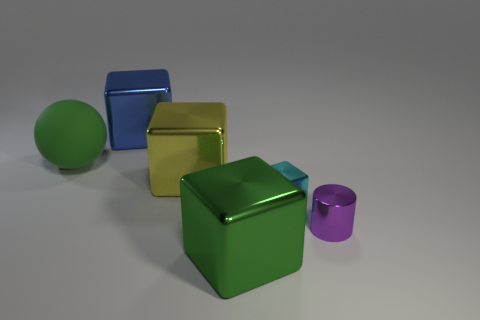Subtract all green blocks. How many blocks are left? 3 Add 3 cylinders. How many objects exist? 9 Subtract all green blocks. How many blocks are left? 3 Subtract all yellow spheres. How many blue cylinders are left? 0 Add 3 small cylinders. How many small cylinders exist? 4 Subtract 1 purple cylinders. How many objects are left? 5 Subtract all cubes. How many objects are left? 2 Subtract all cyan cubes. Subtract all blue balls. How many cubes are left? 3 Subtract all green shiny objects. Subtract all large green things. How many objects are left? 3 Add 2 tiny things. How many tiny things are left? 4 